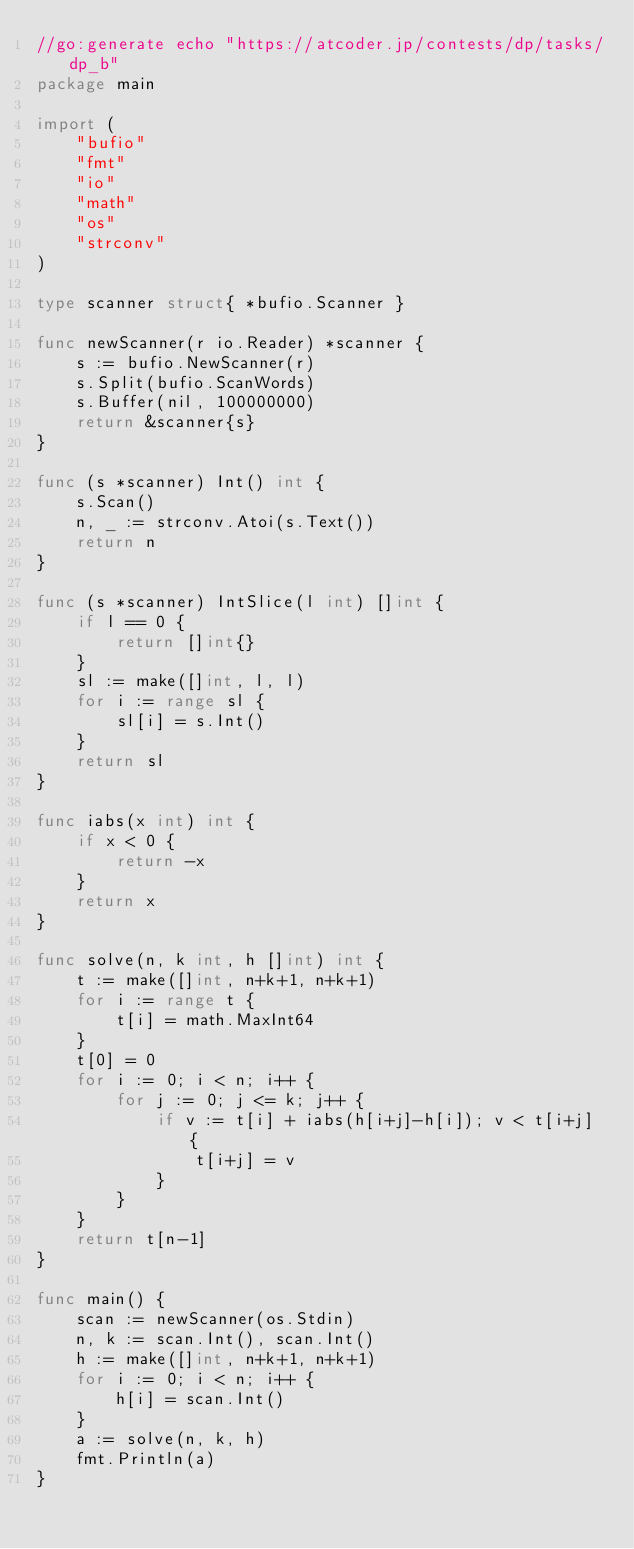Convert code to text. <code><loc_0><loc_0><loc_500><loc_500><_Go_>//go:generate echo "https://atcoder.jp/contests/dp/tasks/dp_b"
package main

import (
	"bufio"
	"fmt"
	"io"
	"math"
	"os"
	"strconv"
)

type scanner struct{ *bufio.Scanner }

func newScanner(r io.Reader) *scanner {
	s := bufio.NewScanner(r)
	s.Split(bufio.ScanWords)
	s.Buffer(nil, 100000000)
	return &scanner{s}
}

func (s *scanner) Int() int {
	s.Scan()
	n, _ := strconv.Atoi(s.Text())
	return n
}

func (s *scanner) IntSlice(l int) []int {
	if l == 0 {
		return []int{}
	}
	sl := make([]int, l, l)
	for i := range sl {
		sl[i] = s.Int()
	}
	return sl
}

func iabs(x int) int {
	if x < 0 {
		return -x
	}
	return x
}

func solve(n, k int, h []int) int {
	t := make([]int, n+k+1, n+k+1)
	for i := range t {
		t[i] = math.MaxInt64
	}
	t[0] = 0
	for i := 0; i < n; i++ {
		for j := 0; j <= k; j++ {
			if v := t[i] + iabs(h[i+j]-h[i]); v < t[i+j] {
				t[i+j] = v
			}
		}
	}
	return t[n-1]
}

func main() {
	scan := newScanner(os.Stdin)
	n, k := scan.Int(), scan.Int()
	h := make([]int, n+k+1, n+k+1)
	for i := 0; i < n; i++ {
		h[i] = scan.Int()
	}
	a := solve(n, k, h)
	fmt.Println(a)
}
</code> 